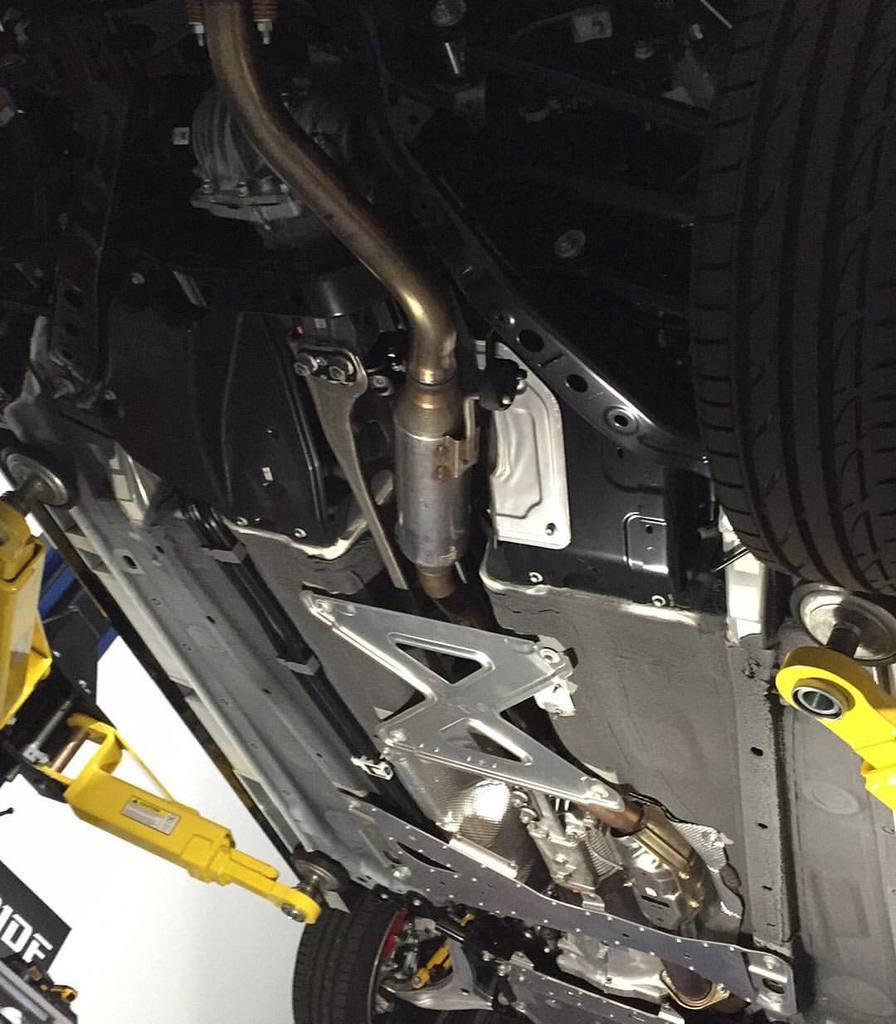In one or two sentences, can you explain what this image depicts? In this image, there is a bottom view of a car. 